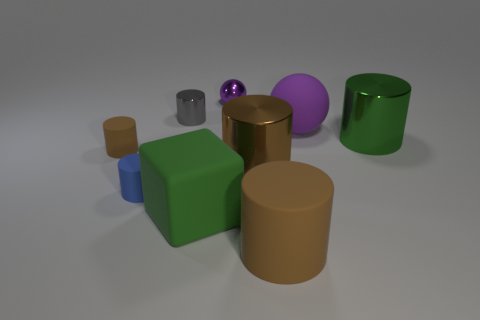There is a brown rubber object right of the shiny object to the left of the purple metal thing; what is its size?
Your answer should be very brief. Large. There is a large ball; is it the same color as the sphere behind the purple matte thing?
Your response must be concise. Yes. What is the material of the brown object that is the same size as the blue rubber cylinder?
Offer a terse response. Rubber. Are there fewer tiny purple shiny spheres that are in front of the blue object than matte cylinders that are to the left of the tiny gray metallic object?
Keep it short and to the point. Yes. There is a matte object that is right of the thing in front of the big green rubber object; what shape is it?
Your answer should be compact. Sphere. Is there a tiny blue shiny cylinder?
Provide a succinct answer. No. What is the color of the metallic cylinder that is behind the matte sphere?
Offer a terse response. Gray. What is the material of the other ball that is the same color as the big ball?
Keep it short and to the point. Metal. There is a brown metal cylinder; are there any big brown rubber things in front of it?
Provide a succinct answer. Yes. Are there more small purple objects than large cyan metallic objects?
Offer a very short reply. Yes. 